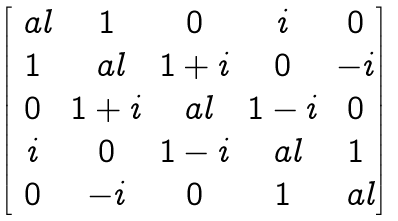Convert formula to latex. <formula><loc_0><loc_0><loc_500><loc_500>\begin{bmatrix} \ a l & 1 & 0 & i & 0 \\ 1 & \ a l & 1 + i & 0 & - i \\ 0 & 1 + i & \ a l & 1 - i & 0 \\ i & 0 & 1 - i & \ a l & 1 \\ 0 & - i & 0 & 1 & \ a l \\ \end{bmatrix}</formula> 